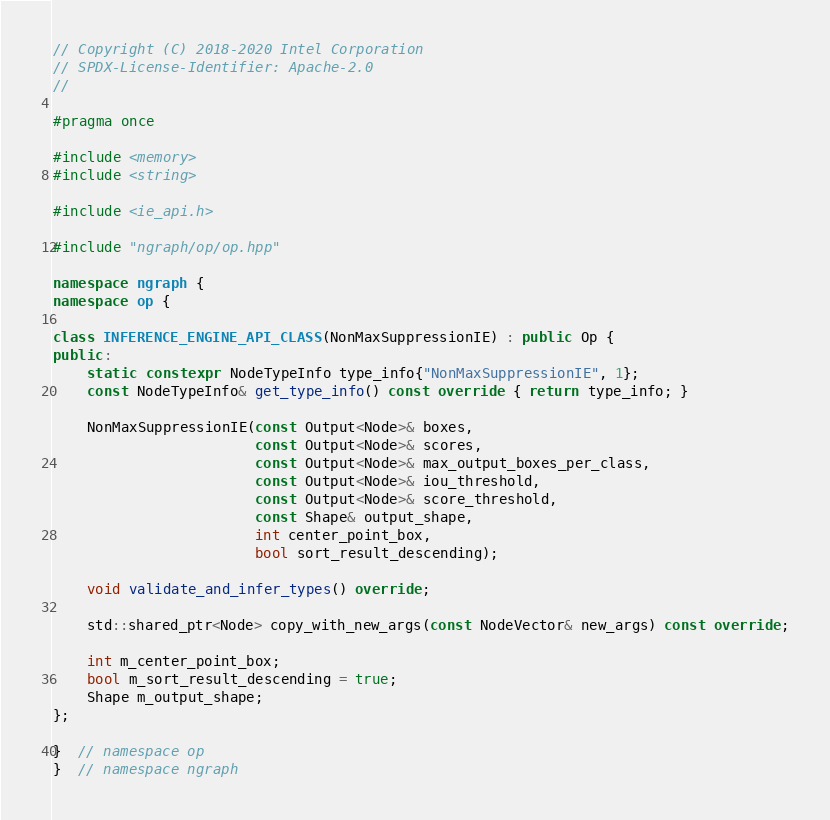<code> <loc_0><loc_0><loc_500><loc_500><_C++_>// Copyright (C) 2018-2020 Intel Corporation
// SPDX-License-Identifier: Apache-2.0
//

#pragma once

#include <memory>
#include <string>

#include <ie_api.h>

#include "ngraph/op/op.hpp"

namespace ngraph {
namespace op {

class INFERENCE_ENGINE_API_CLASS(NonMaxSuppressionIE) : public Op {
public:
    static constexpr NodeTypeInfo type_info{"NonMaxSuppressionIE", 1};
    const NodeTypeInfo& get_type_info() const override { return type_info; }

    NonMaxSuppressionIE(const Output<Node>& boxes,
                        const Output<Node>& scores,
                        const Output<Node>& max_output_boxes_per_class,
                        const Output<Node>& iou_threshold,
                        const Output<Node>& score_threshold,
                        const Shape& output_shape,
                        int center_point_box,
                        bool sort_result_descending);

    void validate_and_infer_types() override;

    std::shared_ptr<Node> copy_with_new_args(const NodeVector& new_args) const override;

    int m_center_point_box;
    bool m_sort_result_descending = true;
    Shape m_output_shape;
};

}  // namespace op
}  // namespace ngraph
</code> 